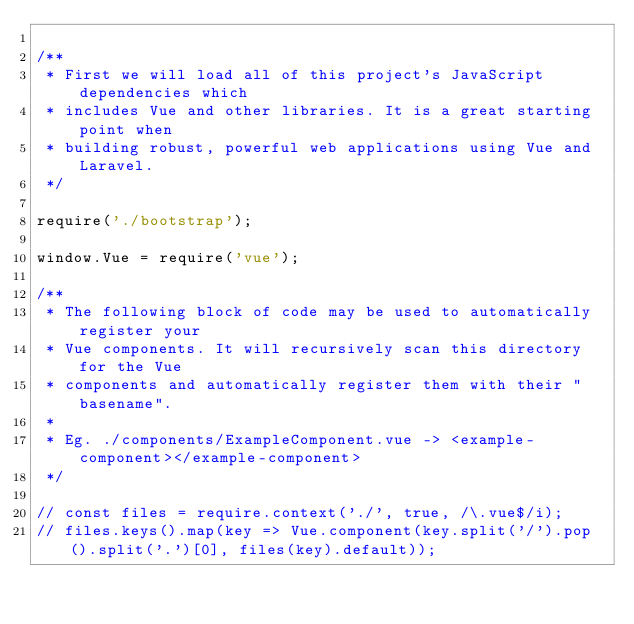<code> <loc_0><loc_0><loc_500><loc_500><_JavaScript_>
/**
 * First we will load all of this project's JavaScript dependencies which
 * includes Vue and other libraries. It is a great starting point when
 * building robust, powerful web applications using Vue and Laravel.
 */

require('./bootstrap');

window.Vue = require('vue');

/**
 * The following block of code may be used to automatically register your
 * Vue components. It will recursively scan this directory for the Vue
 * components and automatically register them with their "basename".
 *
 * Eg. ./components/ExampleComponent.vue -> <example-component></example-component>
 */

// const files = require.context('./', true, /\.vue$/i);
// files.keys().map(key => Vue.component(key.split('/').pop().split('.')[0], files(key).default));
</code> 